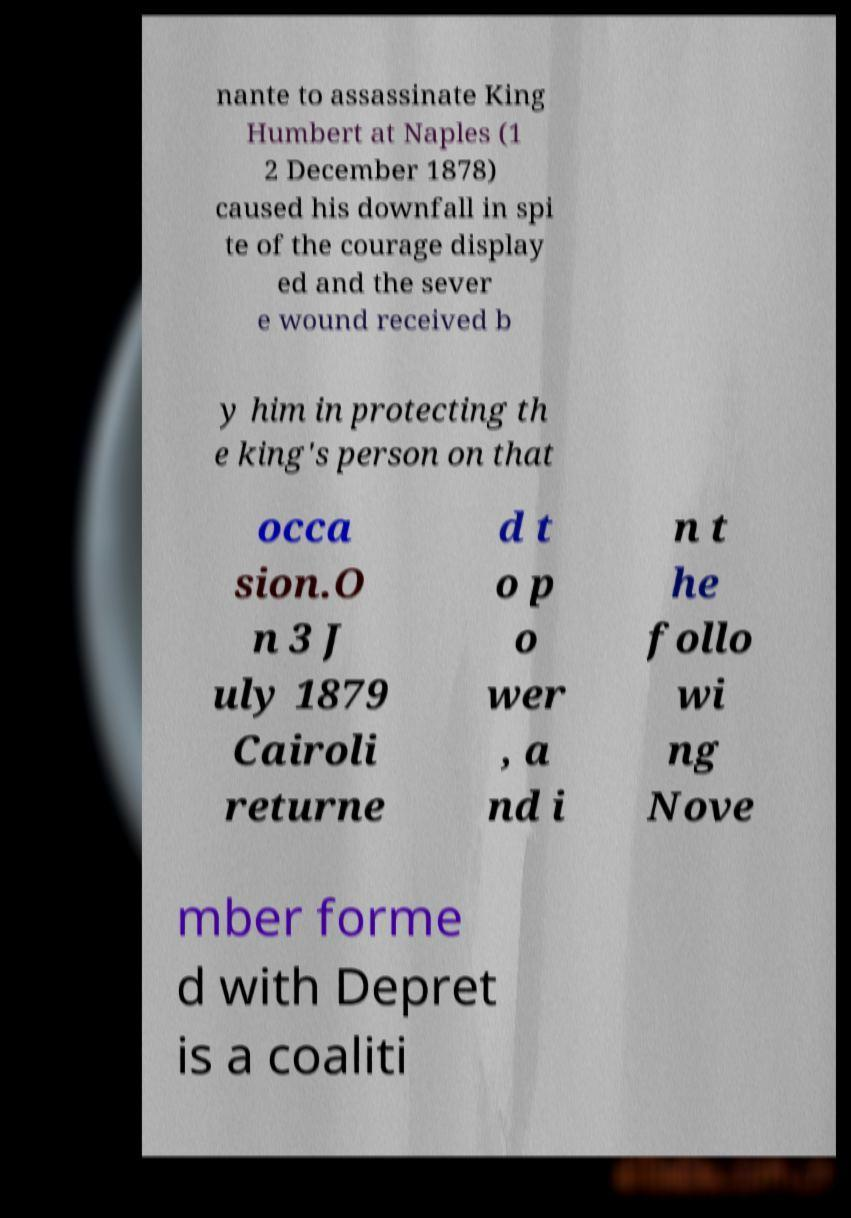Could you assist in decoding the text presented in this image and type it out clearly? nante to assassinate King Humbert at Naples (1 2 December 1878) caused his downfall in spi te of the courage display ed and the sever e wound received b y him in protecting th e king's person on that occa sion.O n 3 J uly 1879 Cairoli returne d t o p o wer , a nd i n t he follo wi ng Nove mber forme d with Depret is a coaliti 